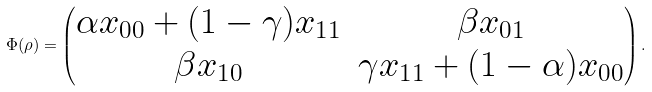Convert formula to latex. <formula><loc_0><loc_0><loc_500><loc_500>\Phi ( \rho ) = \begin{pmatrix} \alpha x _ { 0 0 } + ( 1 - \gamma ) x _ { 1 1 } & \beta x _ { 0 1 } \\ \beta x _ { 1 0 } & \gamma x _ { 1 1 } + ( 1 - \alpha ) x _ { 0 0 } \end{pmatrix} .</formula> 